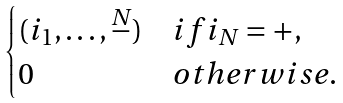Convert formula to latex. <formula><loc_0><loc_0><loc_500><loc_500>\begin{cases} ( i _ { 1 } , \dots , \stackrel { N } { - } ) & i f i _ { N } = + , \\ 0 & o t h e r w i s e . \end{cases}</formula> 